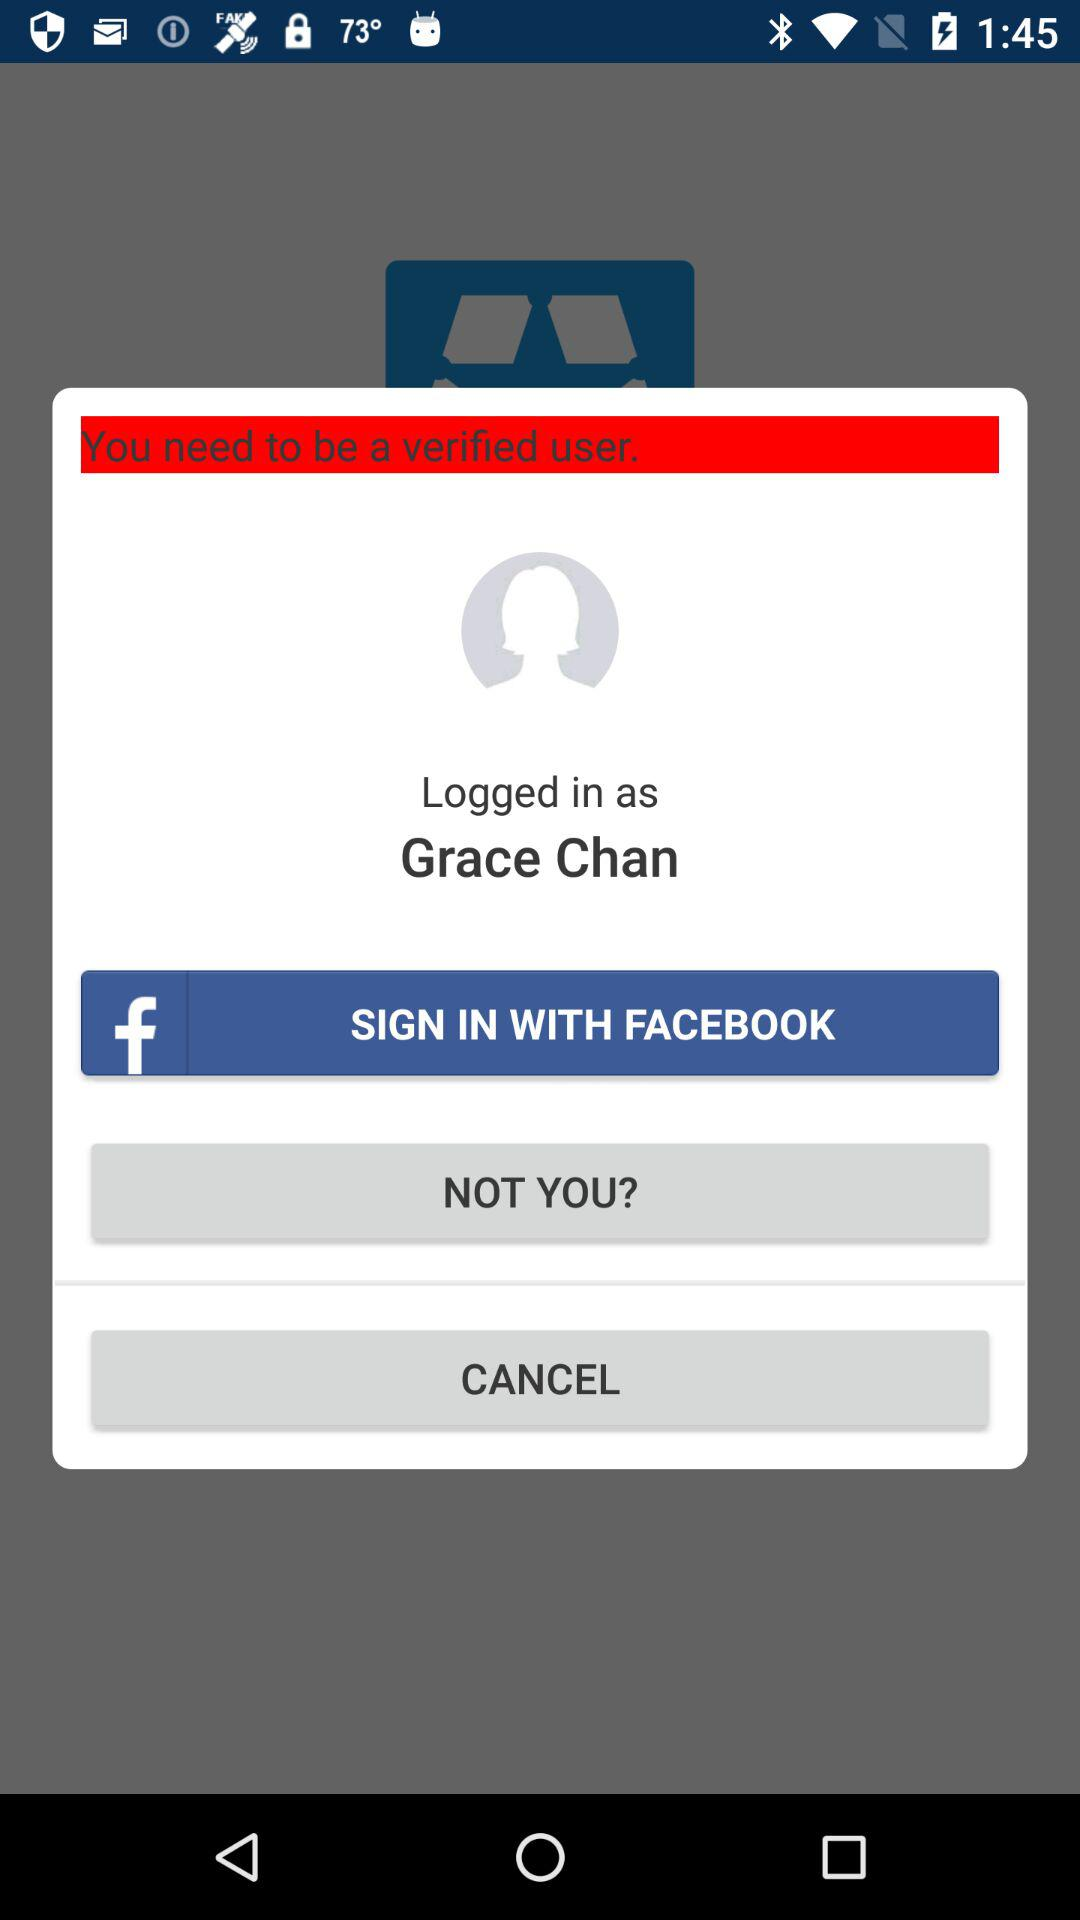What application can we use to log in? You can use "FACEBOOK" to log in. 